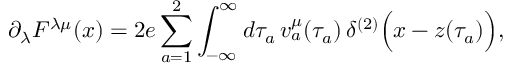<formula> <loc_0><loc_0><loc_500><loc_500>\partial _ { \lambda } F ^ { \lambda \mu } ( x ) = 2 e \sum _ { a = 1 } ^ { 2 } \int _ { - \infty } ^ { \infty } d \tau _ { a } \, { v } _ { a } ^ { \mu } ( \tau _ { a } ) \, \delta ^ { ( 2 ) } \left ( x - z ( \tau _ { a } ) \right ) ,</formula> 